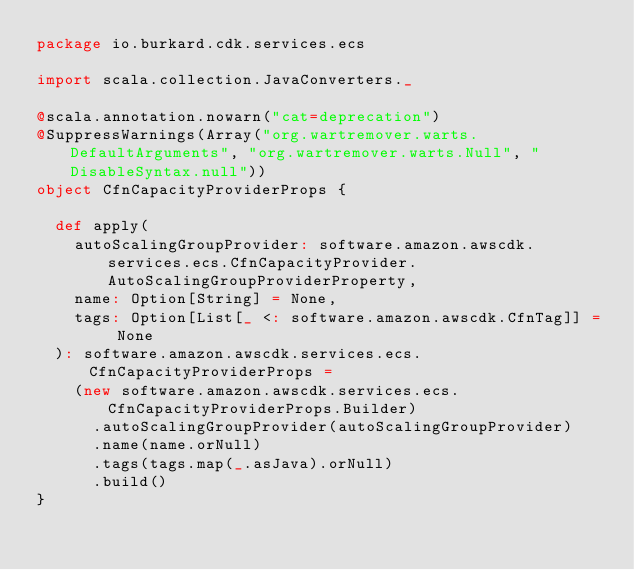Convert code to text. <code><loc_0><loc_0><loc_500><loc_500><_Scala_>package io.burkard.cdk.services.ecs

import scala.collection.JavaConverters._

@scala.annotation.nowarn("cat=deprecation")
@SuppressWarnings(Array("org.wartremover.warts.DefaultArguments", "org.wartremover.warts.Null", "DisableSyntax.null"))
object CfnCapacityProviderProps {

  def apply(
    autoScalingGroupProvider: software.amazon.awscdk.services.ecs.CfnCapacityProvider.AutoScalingGroupProviderProperty,
    name: Option[String] = None,
    tags: Option[List[_ <: software.amazon.awscdk.CfnTag]] = None
  ): software.amazon.awscdk.services.ecs.CfnCapacityProviderProps =
    (new software.amazon.awscdk.services.ecs.CfnCapacityProviderProps.Builder)
      .autoScalingGroupProvider(autoScalingGroupProvider)
      .name(name.orNull)
      .tags(tags.map(_.asJava).orNull)
      .build()
}
</code> 